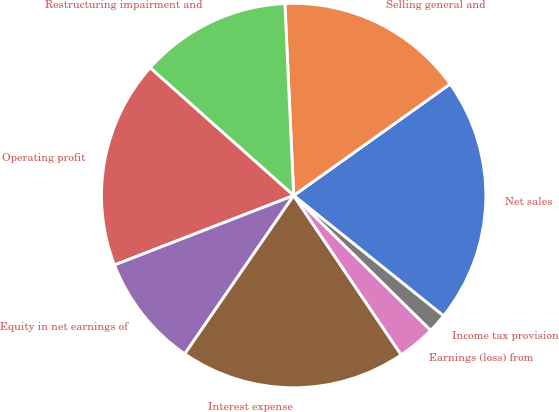<chart> <loc_0><loc_0><loc_500><loc_500><pie_chart><fcel>Net sales<fcel>Selling general and<fcel>Restructuring impairment and<fcel>Operating profit<fcel>Equity in net earnings of<fcel>Interest expense<fcel>Earnings (loss) from<fcel>Income tax provision<nl><fcel>20.63%<fcel>15.87%<fcel>12.7%<fcel>17.46%<fcel>9.53%<fcel>19.04%<fcel>3.18%<fcel>1.6%<nl></chart> 